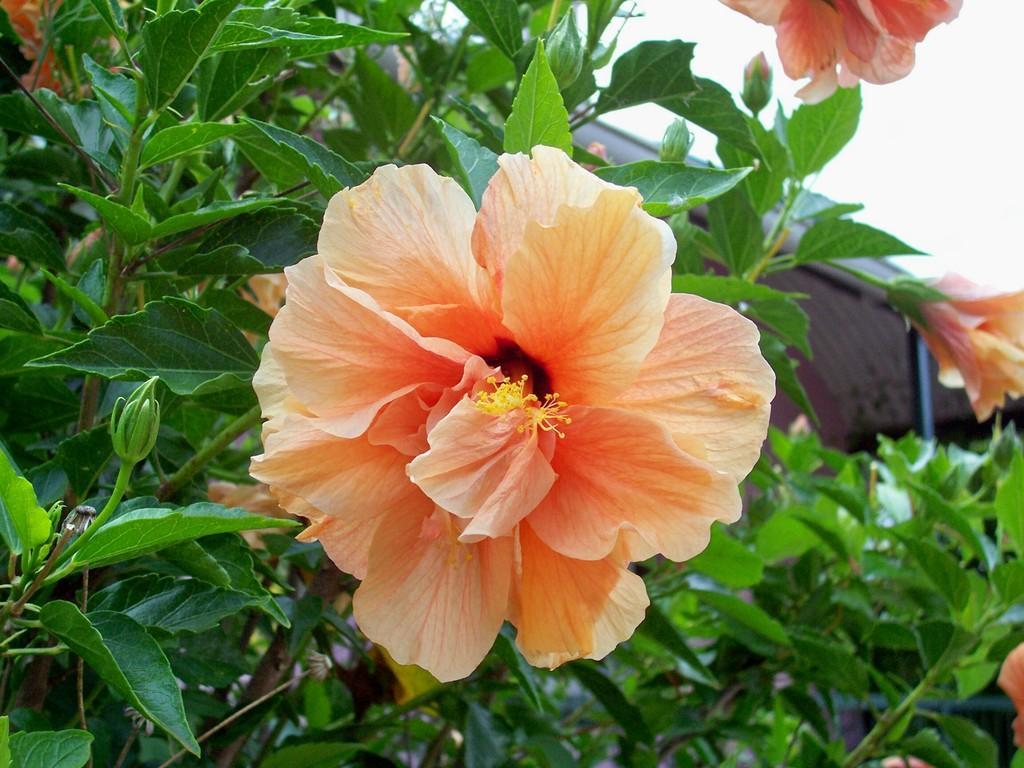How would you summarize this image in a sentence or two? In this image there are plants and we can see flowers on it. 